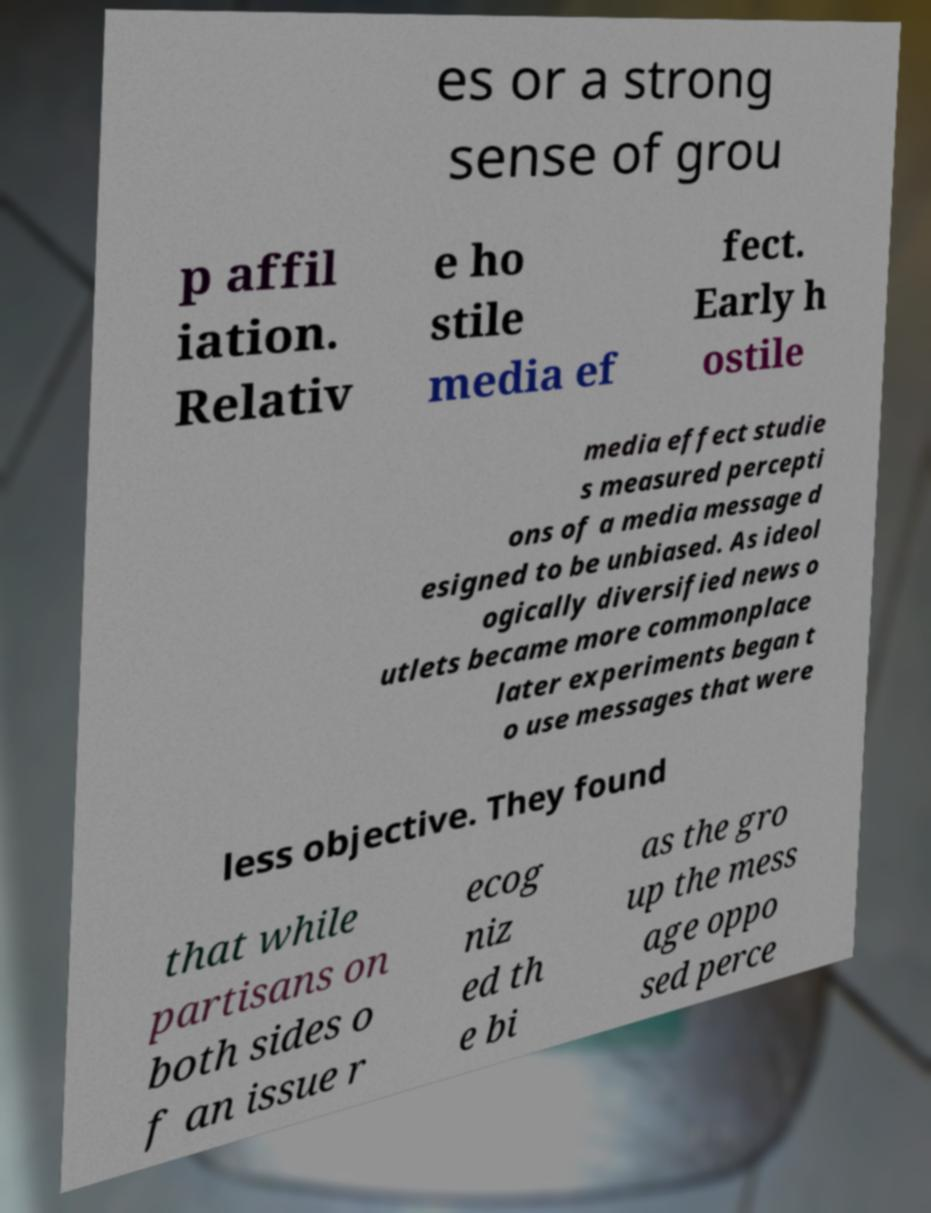Please read and relay the text visible in this image. What does it say? es or a strong sense of grou p affil iation. Relativ e ho stile media ef fect. Early h ostile media effect studie s measured percepti ons of a media message d esigned to be unbiased. As ideol ogically diversified news o utlets became more commonplace later experiments began t o use messages that were less objective. They found that while partisans on both sides o f an issue r ecog niz ed th e bi as the gro up the mess age oppo sed perce 